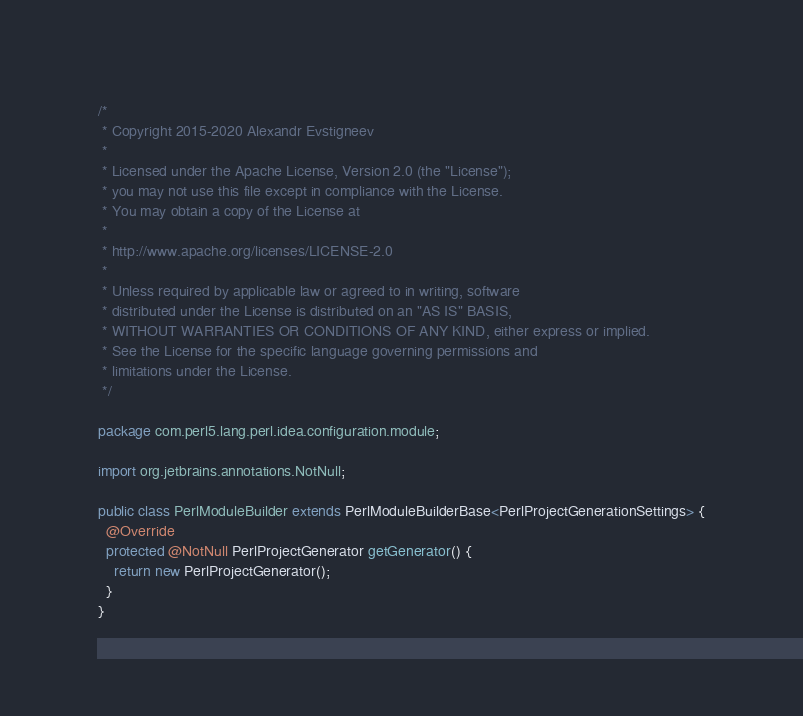<code> <loc_0><loc_0><loc_500><loc_500><_Java_>/*
 * Copyright 2015-2020 Alexandr Evstigneev
 *
 * Licensed under the Apache License, Version 2.0 (the "License");
 * you may not use this file except in compliance with the License.
 * You may obtain a copy of the License at
 *
 * http://www.apache.org/licenses/LICENSE-2.0
 *
 * Unless required by applicable law or agreed to in writing, software
 * distributed under the License is distributed on an "AS IS" BASIS,
 * WITHOUT WARRANTIES OR CONDITIONS OF ANY KIND, either express or implied.
 * See the License for the specific language governing permissions and
 * limitations under the License.
 */

package com.perl5.lang.perl.idea.configuration.module;

import org.jetbrains.annotations.NotNull;

public class PerlModuleBuilder extends PerlModuleBuilderBase<PerlProjectGenerationSettings> {
  @Override
  protected @NotNull PerlProjectGenerator getGenerator() {
    return new PerlProjectGenerator();
  }
}
</code> 